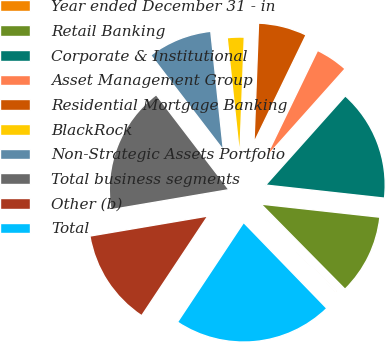Convert chart. <chart><loc_0><loc_0><loc_500><loc_500><pie_chart><fcel>Year ended December 31 - in<fcel>Retail Banking<fcel>Corporate & Institutional<fcel>Asset Management Group<fcel>Residential Mortgage Banking<fcel>BlackRock<fcel>Non-Strategic Assets Portfolio<fcel>Total business segments<fcel>Other (b)<fcel>Total<nl><fcel>0.15%<fcel>10.86%<fcel>15.14%<fcel>4.43%<fcel>6.57%<fcel>2.29%<fcel>8.71%<fcel>17.28%<fcel>13.0%<fcel>21.57%<nl></chart> 